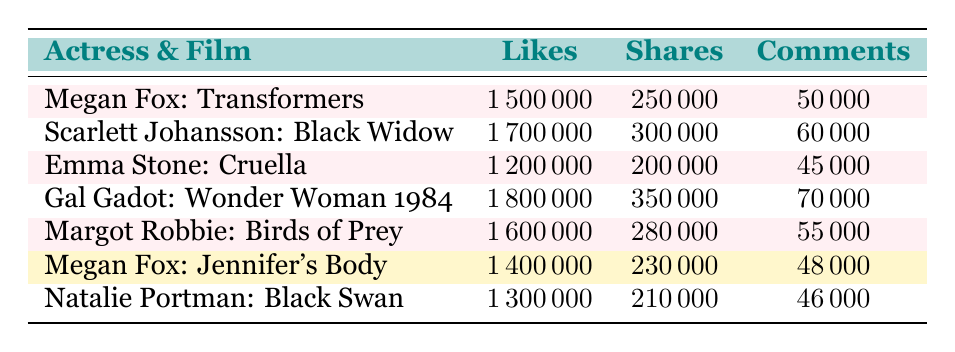What is the highest number of likes associated with a film? The highest number of likes can be found in the "Likes" column. Looking through the values, the highest is 1,800,000 for "Gal Gadot: Wonder Woman 1984."
Answer: 1,800,000 Which film had the least number of comments? The least number of comments can be found by checking the "Comments" column. "Megan Fox: Jennifer's Body" has 48,000 comments, which is the lowest among all listed films.
Answer: 48,000 Is it true that Megan Fox's film "Transformers" has more likes than Margot Robbie's "Birds of Prey"? To determine if this statement is true, we compare the likes for both films. "Transformers" has 1,500,000 likes and "Birds of Prey" has 1,600,000 likes. Since 1,500,000 is less than 1,600,000, the statement is false.
Answer: No What is the average number of shares for Megan Fox's films? Megan Fox's films "Transformers" and "Jennifer's Body" have shares of 250,000 and 230,000, respectively. To find the average, we add the shares (250,000 + 230,000 = 480,000) and divide by the number of films (2), resulting in an average of 240,000 shares.
Answer: 240,000 Which actress received the most comments relative to their likes? To find the actress with the highest ratio of comments to likes, we need to calculate this ratio for each actress. For instance, for Megan Fox's "Transformers," the ratio is 0.033 (50,000/1,500,000). After calculating ratios for all entries, the highest ratio is found for "Natalie Portman: Black Swan," with a ratio of approximately 0.035 (46,000/1,300,000).
Answer: Natalie Portman What is the total number of likes across all films listed? The total number of likes can be calculated by adding the likes from each film. Summing these values (1,500,000 + 1,700,000 + 1,200,000 + 1,800,000 + 1,600,000 + 1,400,000 + 1,300,000) gives a total of 10,700,000 likes.
Answer: 10,700,000 Did any film have more shares than likes? To answer this, we check each film's shares relative to its likes. All films have more likes than shares, meaning none of the films has more shares than likes. Therefore, the answer is no.
Answer: No Which actress promoted the film with the highest engagement metrics (likes + shares + comments)? To identify the actress with the highest engagement metrics, we calculate the total engagement for each film by summing likes, shares, and comments. Upon calculation, "Gal Gadot: Wonder Woman 1984" has the highest total engagement at 1,800,000 + 350,000 + 70,000 = 2,220,000.
Answer: Gal Gadot 